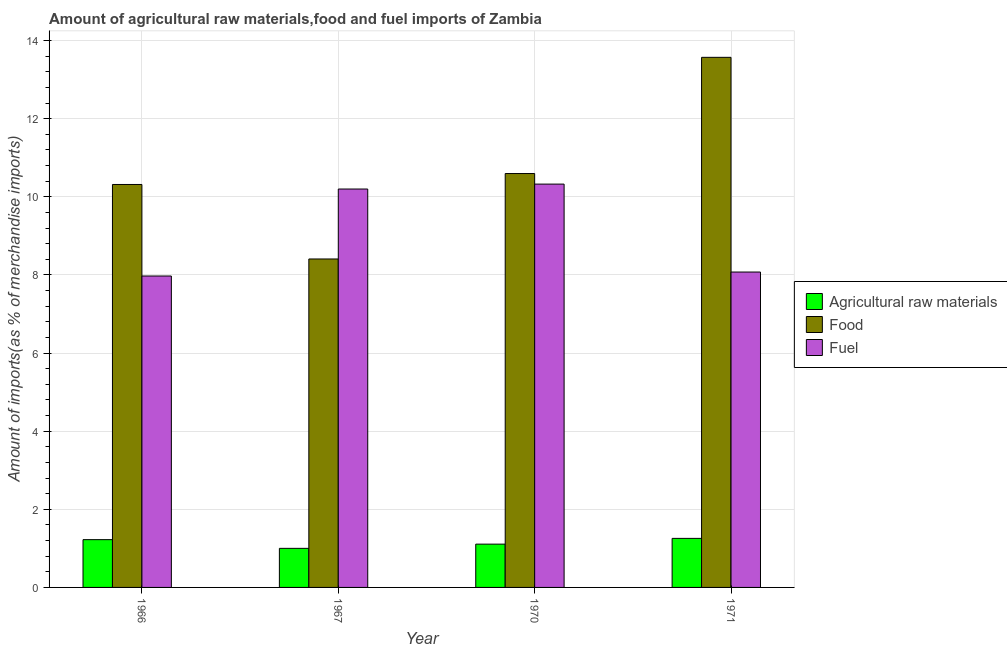Are the number of bars per tick equal to the number of legend labels?
Ensure brevity in your answer.  Yes. Are the number of bars on each tick of the X-axis equal?
Ensure brevity in your answer.  Yes. How many bars are there on the 2nd tick from the left?
Keep it short and to the point. 3. What is the label of the 1st group of bars from the left?
Offer a very short reply. 1966. In how many cases, is the number of bars for a given year not equal to the number of legend labels?
Your response must be concise. 0. What is the percentage of fuel imports in 1966?
Your response must be concise. 7.97. Across all years, what is the maximum percentage of fuel imports?
Keep it short and to the point. 10.33. Across all years, what is the minimum percentage of food imports?
Give a very brief answer. 8.41. In which year was the percentage of fuel imports maximum?
Ensure brevity in your answer.  1970. In which year was the percentage of food imports minimum?
Provide a succinct answer. 1967. What is the total percentage of food imports in the graph?
Offer a terse response. 42.9. What is the difference between the percentage of food imports in 1967 and that in 1970?
Provide a succinct answer. -2.19. What is the difference between the percentage of raw materials imports in 1967 and the percentage of fuel imports in 1970?
Keep it short and to the point. -0.11. What is the average percentage of raw materials imports per year?
Provide a succinct answer. 1.15. In the year 1971, what is the difference between the percentage of food imports and percentage of fuel imports?
Provide a succinct answer. 0. In how many years, is the percentage of raw materials imports greater than 6 %?
Your answer should be very brief. 0. What is the ratio of the percentage of food imports in 1967 to that in 1970?
Make the answer very short. 0.79. Is the percentage of raw materials imports in 1967 less than that in 1971?
Your answer should be very brief. Yes. What is the difference between the highest and the second highest percentage of fuel imports?
Make the answer very short. 0.13. What is the difference between the highest and the lowest percentage of raw materials imports?
Keep it short and to the point. 0.26. Is the sum of the percentage of food imports in 1970 and 1971 greater than the maximum percentage of raw materials imports across all years?
Provide a short and direct response. Yes. What does the 3rd bar from the left in 1966 represents?
Keep it short and to the point. Fuel. What does the 2nd bar from the right in 1966 represents?
Give a very brief answer. Food. How many bars are there?
Ensure brevity in your answer.  12. Are all the bars in the graph horizontal?
Offer a terse response. No. What is the difference between two consecutive major ticks on the Y-axis?
Provide a succinct answer. 2. Are the values on the major ticks of Y-axis written in scientific E-notation?
Offer a terse response. No. Does the graph contain grids?
Offer a terse response. Yes. How many legend labels are there?
Your answer should be compact. 3. How are the legend labels stacked?
Provide a succinct answer. Vertical. What is the title of the graph?
Your answer should be very brief. Amount of agricultural raw materials,food and fuel imports of Zambia. Does "Primary education" appear as one of the legend labels in the graph?
Your response must be concise. No. What is the label or title of the Y-axis?
Keep it short and to the point. Amount of imports(as % of merchandise imports). What is the Amount of imports(as % of merchandise imports) in Agricultural raw materials in 1966?
Provide a succinct answer. 1.22. What is the Amount of imports(as % of merchandise imports) in Food in 1966?
Provide a succinct answer. 10.32. What is the Amount of imports(as % of merchandise imports) in Fuel in 1966?
Provide a short and direct response. 7.97. What is the Amount of imports(as % of merchandise imports) in Agricultural raw materials in 1967?
Keep it short and to the point. 1. What is the Amount of imports(as % of merchandise imports) in Food in 1967?
Ensure brevity in your answer.  8.41. What is the Amount of imports(as % of merchandise imports) of Fuel in 1967?
Offer a terse response. 10.2. What is the Amount of imports(as % of merchandise imports) of Agricultural raw materials in 1970?
Ensure brevity in your answer.  1.11. What is the Amount of imports(as % of merchandise imports) of Food in 1970?
Give a very brief answer. 10.6. What is the Amount of imports(as % of merchandise imports) in Fuel in 1970?
Offer a terse response. 10.33. What is the Amount of imports(as % of merchandise imports) of Agricultural raw materials in 1971?
Ensure brevity in your answer.  1.26. What is the Amount of imports(as % of merchandise imports) of Food in 1971?
Ensure brevity in your answer.  13.57. What is the Amount of imports(as % of merchandise imports) of Fuel in 1971?
Provide a succinct answer. 8.07. Across all years, what is the maximum Amount of imports(as % of merchandise imports) in Agricultural raw materials?
Offer a terse response. 1.26. Across all years, what is the maximum Amount of imports(as % of merchandise imports) of Food?
Make the answer very short. 13.57. Across all years, what is the maximum Amount of imports(as % of merchandise imports) in Fuel?
Keep it short and to the point. 10.33. Across all years, what is the minimum Amount of imports(as % of merchandise imports) of Agricultural raw materials?
Offer a very short reply. 1. Across all years, what is the minimum Amount of imports(as % of merchandise imports) in Food?
Your answer should be compact. 8.41. Across all years, what is the minimum Amount of imports(as % of merchandise imports) in Fuel?
Provide a succinct answer. 7.97. What is the total Amount of imports(as % of merchandise imports) of Agricultural raw materials in the graph?
Give a very brief answer. 4.59. What is the total Amount of imports(as % of merchandise imports) in Food in the graph?
Give a very brief answer. 42.9. What is the total Amount of imports(as % of merchandise imports) in Fuel in the graph?
Make the answer very short. 36.58. What is the difference between the Amount of imports(as % of merchandise imports) in Agricultural raw materials in 1966 and that in 1967?
Your answer should be compact. 0.22. What is the difference between the Amount of imports(as % of merchandise imports) in Food in 1966 and that in 1967?
Provide a short and direct response. 1.91. What is the difference between the Amount of imports(as % of merchandise imports) in Fuel in 1966 and that in 1967?
Give a very brief answer. -2.23. What is the difference between the Amount of imports(as % of merchandise imports) in Agricultural raw materials in 1966 and that in 1970?
Provide a succinct answer. 0.11. What is the difference between the Amount of imports(as % of merchandise imports) in Food in 1966 and that in 1970?
Give a very brief answer. -0.28. What is the difference between the Amount of imports(as % of merchandise imports) of Fuel in 1966 and that in 1970?
Provide a succinct answer. -2.35. What is the difference between the Amount of imports(as % of merchandise imports) in Agricultural raw materials in 1966 and that in 1971?
Ensure brevity in your answer.  -0.03. What is the difference between the Amount of imports(as % of merchandise imports) of Food in 1966 and that in 1971?
Offer a very short reply. -3.26. What is the difference between the Amount of imports(as % of merchandise imports) of Fuel in 1966 and that in 1971?
Ensure brevity in your answer.  -0.1. What is the difference between the Amount of imports(as % of merchandise imports) in Agricultural raw materials in 1967 and that in 1970?
Keep it short and to the point. -0.11. What is the difference between the Amount of imports(as % of merchandise imports) of Food in 1967 and that in 1970?
Provide a succinct answer. -2.19. What is the difference between the Amount of imports(as % of merchandise imports) in Fuel in 1967 and that in 1970?
Provide a short and direct response. -0.13. What is the difference between the Amount of imports(as % of merchandise imports) of Agricultural raw materials in 1967 and that in 1971?
Keep it short and to the point. -0.26. What is the difference between the Amount of imports(as % of merchandise imports) of Food in 1967 and that in 1971?
Your answer should be very brief. -5.16. What is the difference between the Amount of imports(as % of merchandise imports) in Fuel in 1967 and that in 1971?
Provide a succinct answer. 2.13. What is the difference between the Amount of imports(as % of merchandise imports) in Agricultural raw materials in 1970 and that in 1971?
Offer a very short reply. -0.15. What is the difference between the Amount of imports(as % of merchandise imports) in Food in 1970 and that in 1971?
Provide a succinct answer. -2.98. What is the difference between the Amount of imports(as % of merchandise imports) in Fuel in 1970 and that in 1971?
Make the answer very short. 2.25. What is the difference between the Amount of imports(as % of merchandise imports) in Agricultural raw materials in 1966 and the Amount of imports(as % of merchandise imports) in Food in 1967?
Give a very brief answer. -7.19. What is the difference between the Amount of imports(as % of merchandise imports) of Agricultural raw materials in 1966 and the Amount of imports(as % of merchandise imports) of Fuel in 1967?
Offer a terse response. -8.98. What is the difference between the Amount of imports(as % of merchandise imports) of Food in 1966 and the Amount of imports(as % of merchandise imports) of Fuel in 1967?
Offer a terse response. 0.12. What is the difference between the Amount of imports(as % of merchandise imports) of Agricultural raw materials in 1966 and the Amount of imports(as % of merchandise imports) of Food in 1970?
Your answer should be very brief. -9.37. What is the difference between the Amount of imports(as % of merchandise imports) in Agricultural raw materials in 1966 and the Amount of imports(as % of merchandise imports) in Fuel in 1970?
Provide a short and direct response. -9.1. What is the difference between the Amount of imports(as % of merchandise imports) of Food in 1966 and the Amount of imports(as % of merchandise imports) of Fuel in 1970?
Offer a very short reply. -0.01. What is the difference between the Amount of imports(as % of merchandise imports) of Agricultural raw materials in 1966 and the Amount of imports(as % of merchandise imports) of Food in 1971?
Your response must be concise. -12.35. What is the difference between the Amount of imports(as % of merchandise imports) of Agricultural raw materials in 1966 and the Amount of imports(as % of merchandise imports) of Fuel in 1971?
Your response must be concise. -6.85. What is the difference between the Amount of imports(as % of merchandise imports) in Food in 1966 and the Amount of imports(as % of merchandise imports) in Fuel in 1971?
Give a very brief answer. 2.24. What is the difference between the Amount of imports(as % of merchandise imports) of Agricultural raw materials in 1967 and the Amount of imports(as % of merchandise imports) of Food in 1970?
Provide a short and direct response. -9.6. What is the difference between the Amount of imports(as % of merchandise imports) in Agricultural raw materials in 1967 and the Amount of imports(as % of merchandise imports) in Fuel in 1970?
Your response must be concise. -9.33. What is the difference between the Amount of imports(as % of merchandise imports) of Food in 1967 and the Amount of imports(as % of merchandise imports) of Fuel in 1970?
Offer a very short reply. -1.92. What is the difference between the Amount of imports(as % of merchandise imports) of Agricultural raw materials in 1967 and the Amount of imports(as % of merchandise imports) of Food in 1971?
Give a very brief answer. -12.57. What is the difference between the Amount of imports(as % of merchandise imports) in Agricultural raw materials in 1967 and the Amount of imports(as % of merchandise imports) in Fuel in 1971?
Provide a short and direct response. -7.07. What is the difference between the Amount of imports(as % of merchandise imports) in Food in 1967 and the Amount of imports(as % of merchandise imports) in Fuel in 1971?
Your response must be concise. 0.33. What is the difference between the Amount of imports(as % of merchandise imports) in Agricultural raw materials in 1970 and the Amount of imports(as % of merchandise imports) in Food in 1971?
Make the answer very short. -12.46. What is the difference between the Amount of imports(as % of merchandise imports) in Agricultural raw materials in 1970 and the Amount of imports(as % of merchandise imports) in Fuel in 1971?
Your response must be concise. -6.97. What is the difference between the Amount of imports(as % of merchandise imports) of Food in 1970 and the Amount of imports(as % of merchandise imports) of Fuel in 1971?
Ensure brevity in your answer.  2.52. What is the average Amount of imports(as % of merchandise imports) in Agricultural raw materials per year?
Give a very brief answer. 1.15. What is the average Amount of imports(as % of merchandise imports) in Food per year?
Offer a terse response. 10.72. What is the average Amount of imports(as % of merchandise imports) of Fuel per year?
Give a very brief answer. 9.14. In the year 1966, what is the difference between the Amount of imports(as % of merchandise imports) of Agricultural raw materials and Amount of imports(as % of merchandise imports) of Food?
Your answer should be compact. -9.09. In the year 1966, what is the difference between the Amount of imports(as % of merchandise imports) of Agricultural raw materials and Amount of imports(as % of merchandise imports) of Fuel?
Offer a terse response. -6.75. In the year 1966, what is the difference between the Amount of imports(as % of merchandise imports) in Food and Amount of imports(as % of merchandise imports) in Fuel?
Ensure brevity in your answer.  2.34. In the year 1967, what is the difference between the Amount of imports(as % of merchandise imports) of Agricultural raw materials and Amount of imports(as % of merchandise imports) of Food?
Provide a short and direct response. -7.41. In the year 1967, what is the difference between the Amount of imports(as % of merchandise imports) in Agricultural raw materials and Amount of imports(as % of merchandise imports) in Fuel?
Your response must be concise. -9.2. In the year 1967, what is the difference between the Amount of imports(as % of merchandise imports) in Food and Amount of imports(as % of merchandise imports) in Fuel?
Your answer should be very brief. -1.79. In the year 1970, what is the difference between the Amount of imports(as % of merchandise imports) in Agricultural raw materials and Amount of imports(as % of merchandise imports) in Food?
Offer a terse response. -9.49. In the year 1970, what is the difference between the Amount of imports(as % of merchandise imports) in Agricultural raw materials and Amount of imports(as % of merchandise imports) in Fuel?
Your answer should be very brief. -9.22. In the year 1970, what is the difference between the Amount of imports(as % of merchandise imports) in Food and Amount of imports(as % of merchandise imports) in Fuel?
Give a very brief answer. 0.27. In the year 1971, what is the difference between the Amount of imports(as % of merchandise imports) in Agricultural raw materials and Amount of imports(as % of merchandise imports) in Food?
Give a very brief answer. -12.32. In the year 1971, what is the difference between the Amount of imports(as % of merchandise imports) in Agricultural raw materials and Amount of imports(as % of merchandise imports) in Fuel?
Keep it short and to the point. -6.82. In the year 1971, what is the difference between the Amount of imports(as % of merchandise imports) in Food and Amount of imports(as % of merchandise imports) in Fuel?
Offer a terse response. 5.5. What is the ratio of the Amount of imports(as % of merchandise imports) in Agricultural raw materials in 1966 to that in 1967?
Offer a very short reply. 1.22. What is the ratio of the Amount of imports(as % of merchandise imports) in Food in 1966 to that in 1967?
Offer a very short reply. 1.23. What is the ratio of the Amount of imports(as % of merchandise imports) of Fuel in 1966 to that in 1967?
Offer a terse response. 0.78. What is the ratio of the Amount of imports(as % of merchandise imports) of Agricultural raw materials in 1966 to that in 1970?
Give a very brief answer. 1.1. What is the ratio of the Amount of imports(as % of merchandise imports) of Food in 1966 to that in 1970?
Your answer should be compact. 0.97. What is the ratio of the Amount of imports(as % of merchandise imports) in Fuel in 1966 to that in 1970?
Keep it short and to the point. 0.77. What is the ratio of the Amount of imports(as % of merchandise imports) in Agricultural raw materials in 1966 to that in 1971?
Your answer should be very brief. 0.97. What is the ratio of the Amount of imports(as % of merchandise imports) of Food in 1966 to that in 1971?
Provide a succinct answer. 0.76. What is the ratio of the Amount of imports(as % of merchandise imports) in Fuel in 1966 to that in 1971?
Provide a short and direct response. 0.99. What is the ratio of the Amount of imports(as % of merchandise imports) of Agricultural raw materials in 1967 to that in 1970?
Make the answer very short. 0.9. What is the ratio of the Amount of imports(as % of merchandise imports) of Food in 1967 to that in 1970?
Your answer should be compact. 0.79. What is the ratio of the Amount of imports(as % of merchandise imports) of Fuel in 1967 to that in 1970?
Ensure brevity in your answer.  0.99. What is the ratio of the Amount of imports(as % of merchandise imports) of Agricultural raw materials in 1967 to that in 1971?
Give a very brief answer. 0.8. What is the ratio of the Amount of imports(as % of merchandise imports) of Food in 1967 to that in 1971?
Keep it short and to the point. 0.62. What is the ratio of the Amount of imports(as % of merchandise imports) in Fuel in 1967 to that in 1971?
Keep it short and to the point. 1.26. What is the ratio of the Amount of imports(as % of merchandise imports) of Agricultural raw materials in 1970 to that in 1971?
Ensure brevity in your answer.  0.88. What is the ratio of the Amount of imports(as % of merchandise imports) of Food in 1970 to that in 1971?
Provide a short and direct response. 0.78. What is the ratio of the Amount of imports(as % of merchandise imports) in Fuel in 1970 to that in 1971?
Provide a succinct answer. 1.28. What is the difference between the highest and the second highest Amount of imports(as % of merchandise imports) of Agricultural raw materials?
Your response must be concise. 0.03. What is the difference between the highest and the second highest Amount of imports(as % of merchandise imports) in Food?
Ensure brevity in your answer.  2.98. What is the difference between the highest and the second highest Amount of imports(as % of merchandise imports) of Fuel?
Provide a short and direct response. 0.13. What is the difference between the highest and the lowest Amount of imports(as % of merchandise imports) of Agricultural raw materials?
Your answer should be very brief. 0.26. What is the difference between the highest and the lowest Amount of imports(as % of merchandise imports) in Food?
Make the answer very short. 5.16. What is the difference between the highest and the lowest Amount of imports(as % of merchandise imports) in Fuel?
Your answer should be compact. 2.35. 